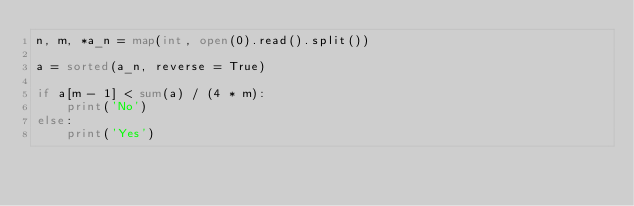<code> <loc_0><loc_0><loc_500><loc_500><_Python_>n, m, *a_n = map(int, open(0).read().split())

a = sorted(a_n, reverse = True)

if a[m - 1] < sum(a) / (4 * m):
    print('No')
else:
    print('Yes')</code> 